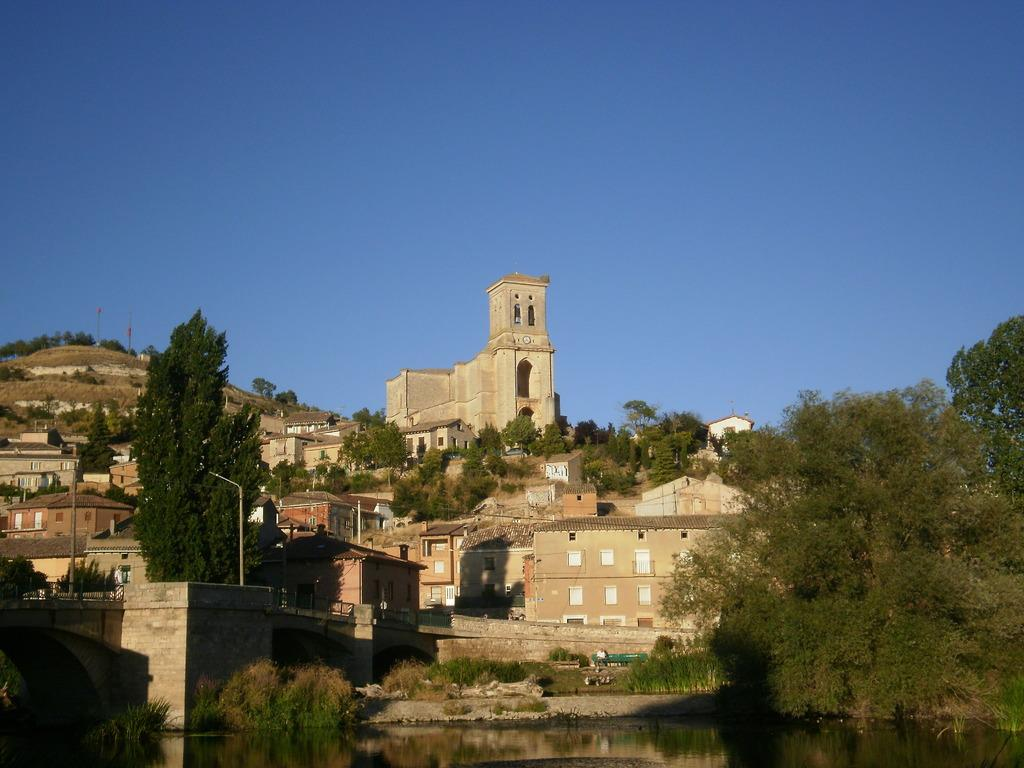What can be seen on the hill in the image? There are buildings and trees on the hill in the image. What is visible at the bottom of the hill in the image? There is water visible at the bottom of the image. What is visible in the background of the image? The sky is visible in the background of the image. What type of advertisement can be seen on the hill in the image? There is no advertisement present in the image; it features buildings, trees, water, and the sky. What type of furniture is visible in the image? There is no furniture present in the image. 